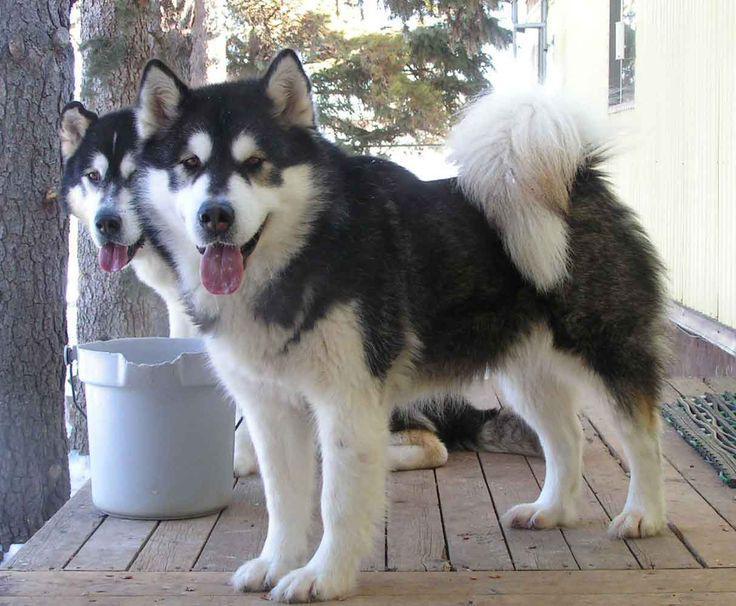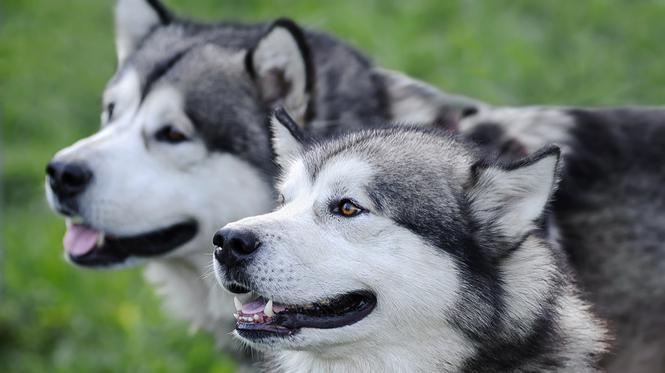The first image is the image on the left, the second image is the image on the right. Evaluate the accuracy of this statement regarding the images: "The left image contains two dogs surrounded by snow.". Is it true? Answer yes or no. No. The first image is the image on the left, the second image is the image on the right. For the images shown, is this caption "The left and right images contain pairs of husky dogs in the snow, and at least some dogs are 'hitched' with ropes." true? Answer yes or no. No. 